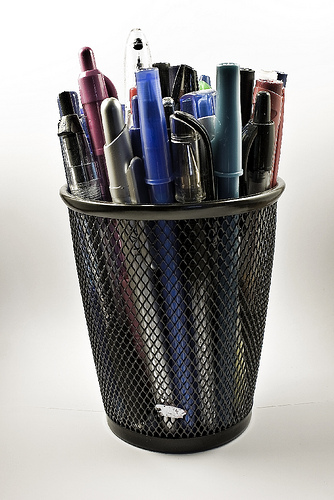<image>
Is there a pens next to the cup? No. The pens is not positioned next to the cup. They are located in different areas of the scene. Is there a pen in the cup? Yes. The pen is contained within or inside the cup, showing a containment relationship. Is the pen on the desk? No. The pen is not positioned on the desk. They may be near each other, but the pen is not supported by or resting on top of the desk. 